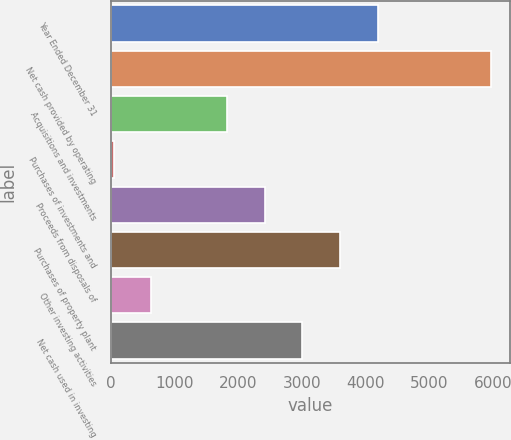<chart> <loc_0><loc_0><loc_500><loc_500><bar_chart><fcel>Year Ended December 31<fcel>Net cash provided by operating<fcel>Acquisitions and investments<fcel>Purchases of investments and<fcel>Proceeds from disposals of<fcel>Purchases of property plant<fcel>Other investing activities<fcel>Net cash used in investing<nl><fcel>4191.4<fcel>5968<fcel>1822.6<fcel>46<fcel>2414.8<fcel>3599.2<fcel>638.2<fcel>3007<nl></chart> 